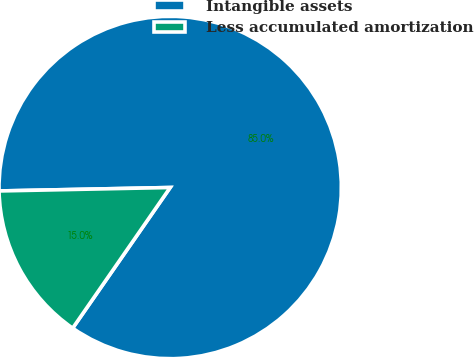Convert chart. <chart><loc_0><loc_0><loc_500><loc_500><pie_chart><fcel>Intangible assets<fcel>Less accumulated amortization<nl><fcel>84.97%<fcel>15.03%<nl></chart> 